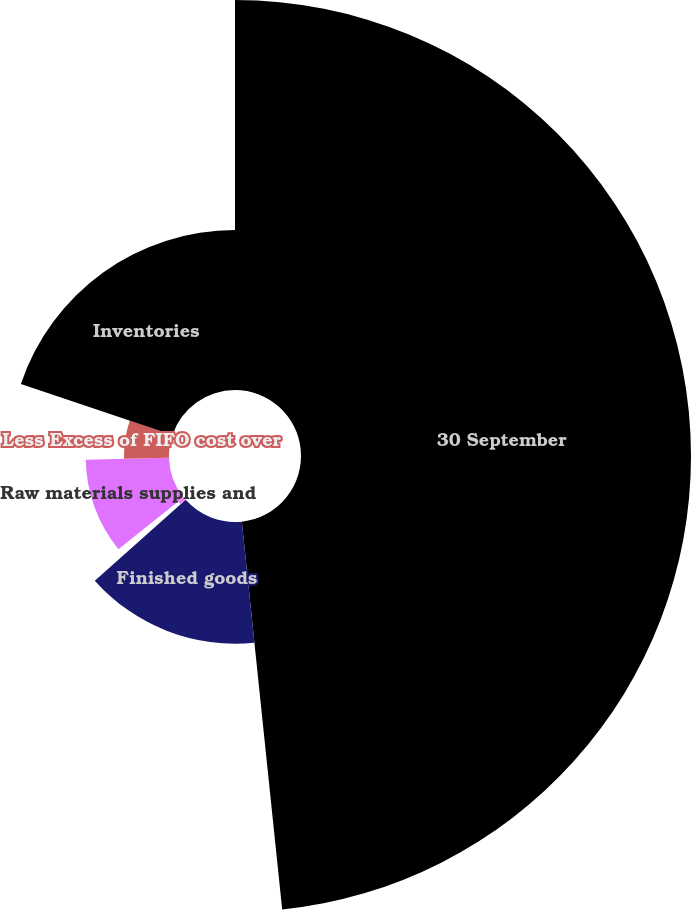Convert chart to OTSL. <chart><loc_0><loc_0><loc_500><loc_500><pie_chart><fcel>30 September<fcel>Finished goods<fcel>Work in process<fcel>Raw materials supplies and<fcel>Less Excess of FIFO cost over<fcel>Inventories<nl><fcel>48.35%<fcel>15.08%<fcel>0.83%<fcel>10.33%<fcel>5.58%<fcel>19.83%<nl></chart> 